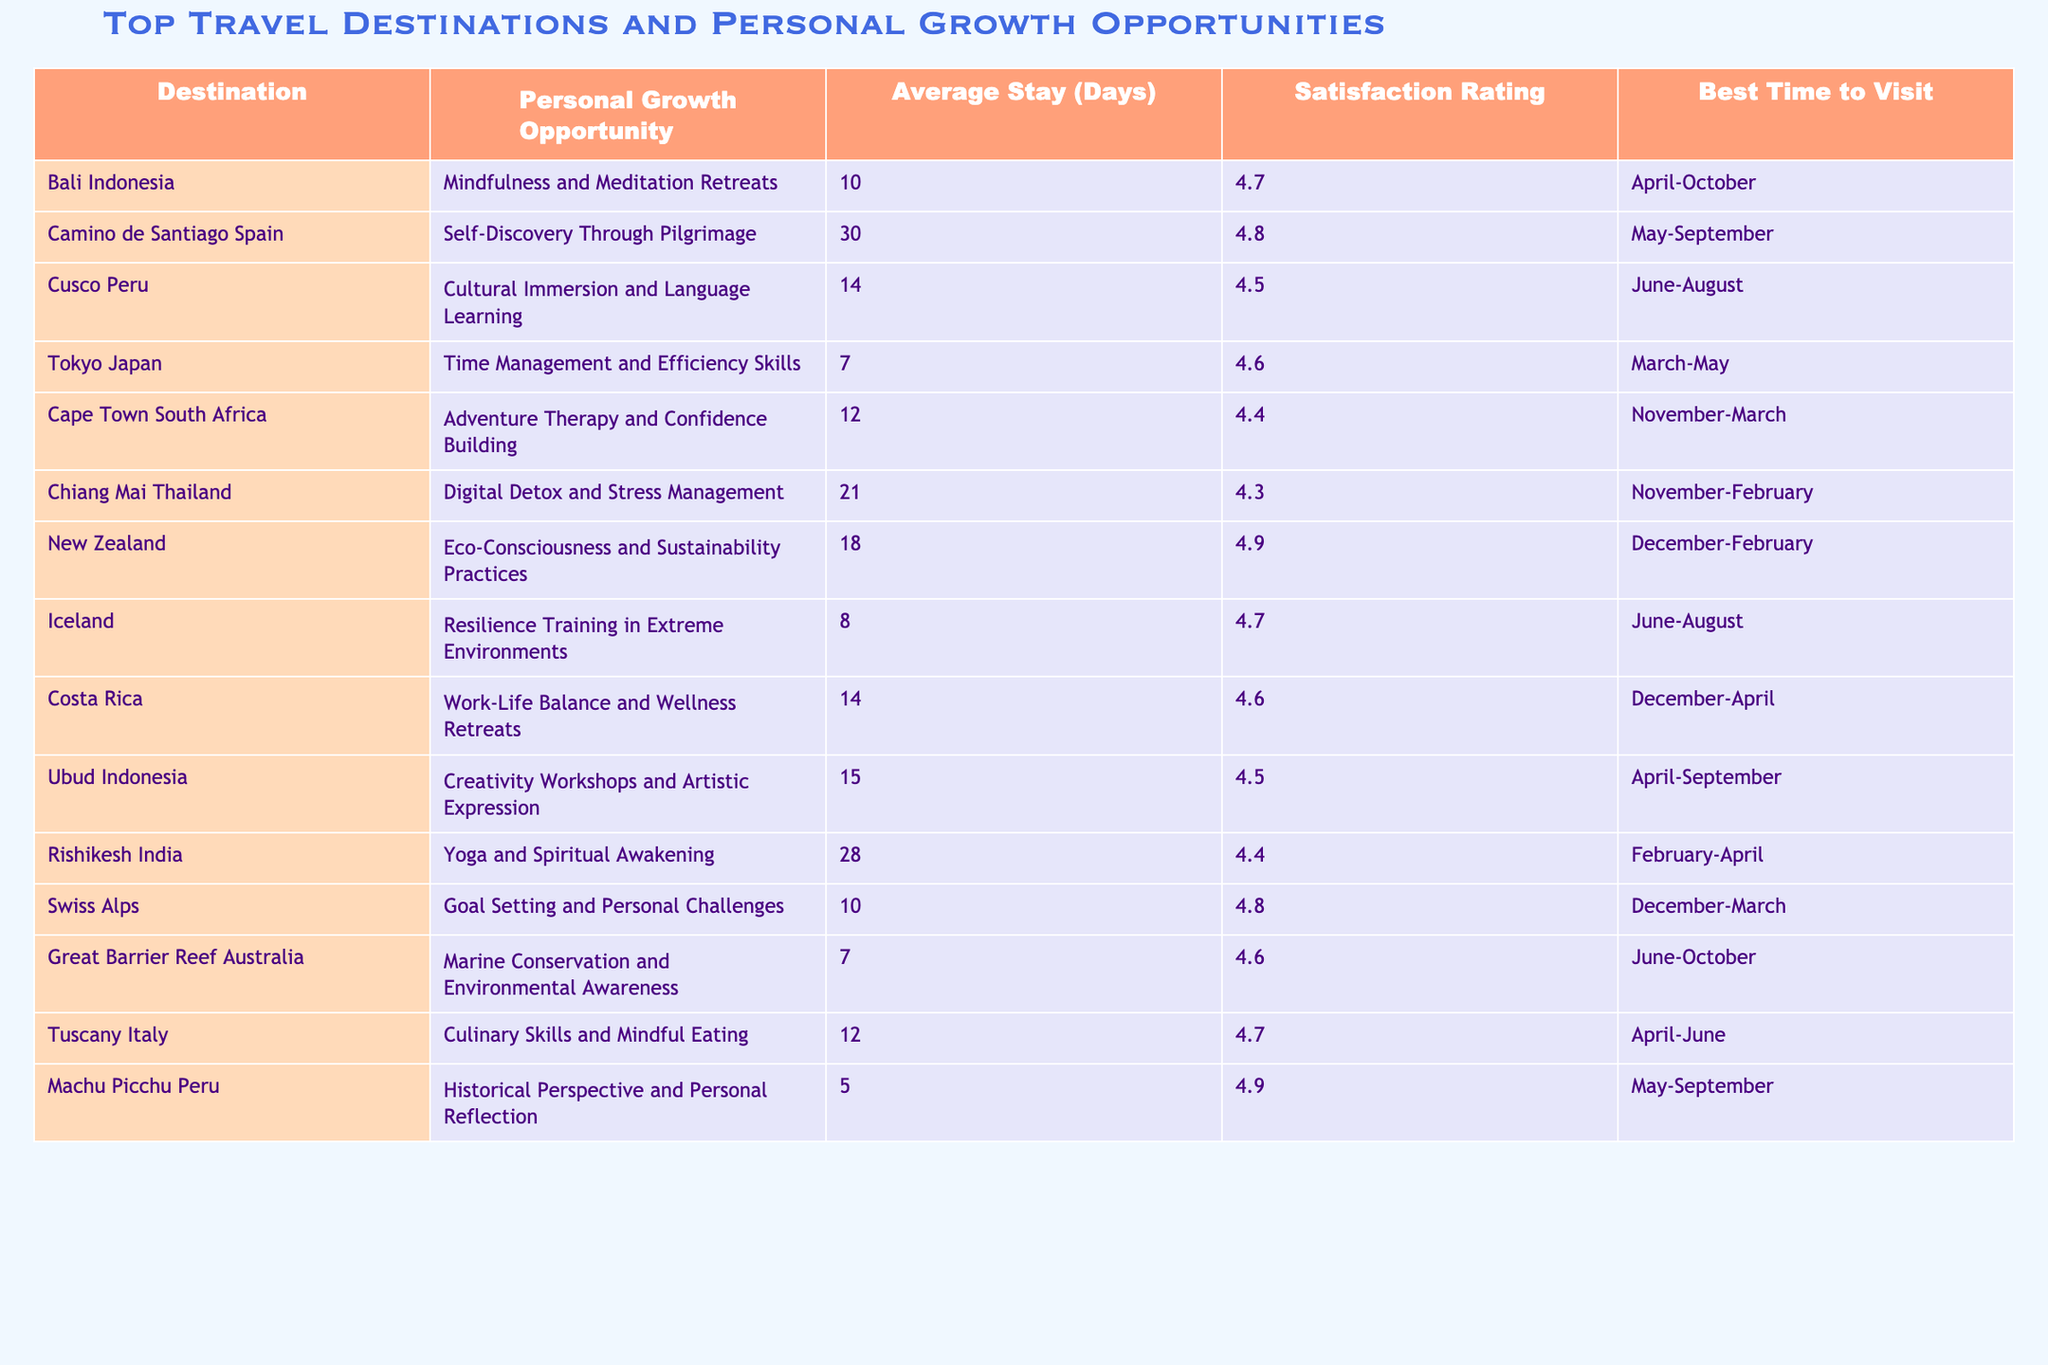What is the satisfaction rating for Bali, Indonesia? The table lists Bali, Indonesia with a satisfaction rating of 4.7.
Answer: 4.7 Which destination is associated with adventure therapy and confidence building? The table shows that Cape Town, South Africa is linked to adventure therapy and confidence building.
Answer: Cape Town, South Africa What is the average stay duration for the Camino de Santiago in Spain? According to the table, the average stay duration for the Camino de Santiago is 30 days.
Answer: 30 days Which destination offers culinary skills and mindful eating as a personal growth opportunity? The table indicates that Tuscany, Italy provides culinary skills and mindful eating opportunities.
Answer: Tuscany, Italy What is the best time to visit Cusco, Peru? The table states that the best time to visit Cusco, Peru is between June and August.
Answer: June-August Which two destinations have the highest satisfaction ratings? By examining the table, New Zealand (4.9) and Machu Picchu (4.9) both have the highest satisfaction ratings.
Answer: New Zealand and Machu Picchu What is the difference in average stay duration between Rishikesh, India, and Tokyo, Japan? Rishikesh has an average stay of 28 days and Tokyo has 7 days, so the difference is 28 - 7 = 21 days.
Answer: 21 days Which destination focused on digital detox and stress management has the lowest satisfaction rating? Analyzing the table, Chiang Mai, Thailand, which has a satisfaction rating of 4.3, focuses on digital detox and stress management while being the lowest in this category.
Answer: Chiang Mai, Thailand Is it true that the Great Barrier Reef, Australia has a satisfaction rating higher than 4.5? Looking at the table, the Great Barrier Reef has a satisfaction rating of 4.6, which is indeed higher than 4.5.
Answer: Yes What is the average satisfaction rating for destinations that emphasize creativity workshops or artistic expression? The relevant destinations are Ubud, Indonesia (4.5) and none other, thus the average is 4.5.
Answer: 4.5 